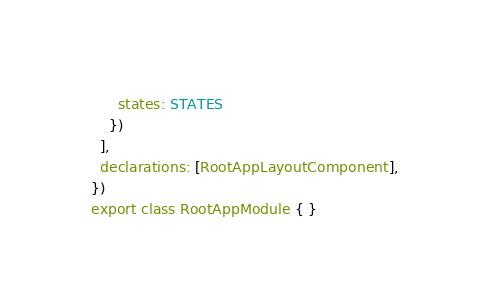Convert code to text. <code><loc_0><loc_0><loc_500><loc_500><_TypeScript_>      states: STATES
    })
  ],
  declarations: [RootAppLayoutComponent],
})
export class RootAppModule { }
</code> 